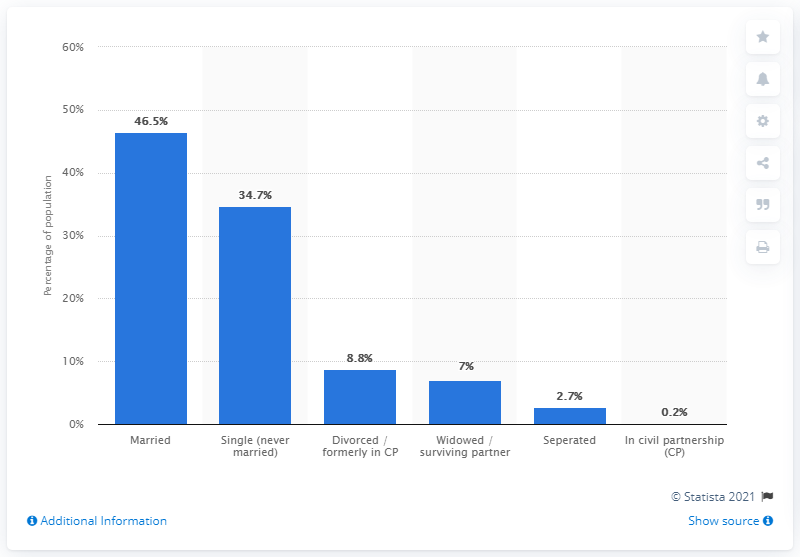Draw attention to some important aspects in this diagram. According to recent statistics, only 0.2% of the population is in a civil partnership 